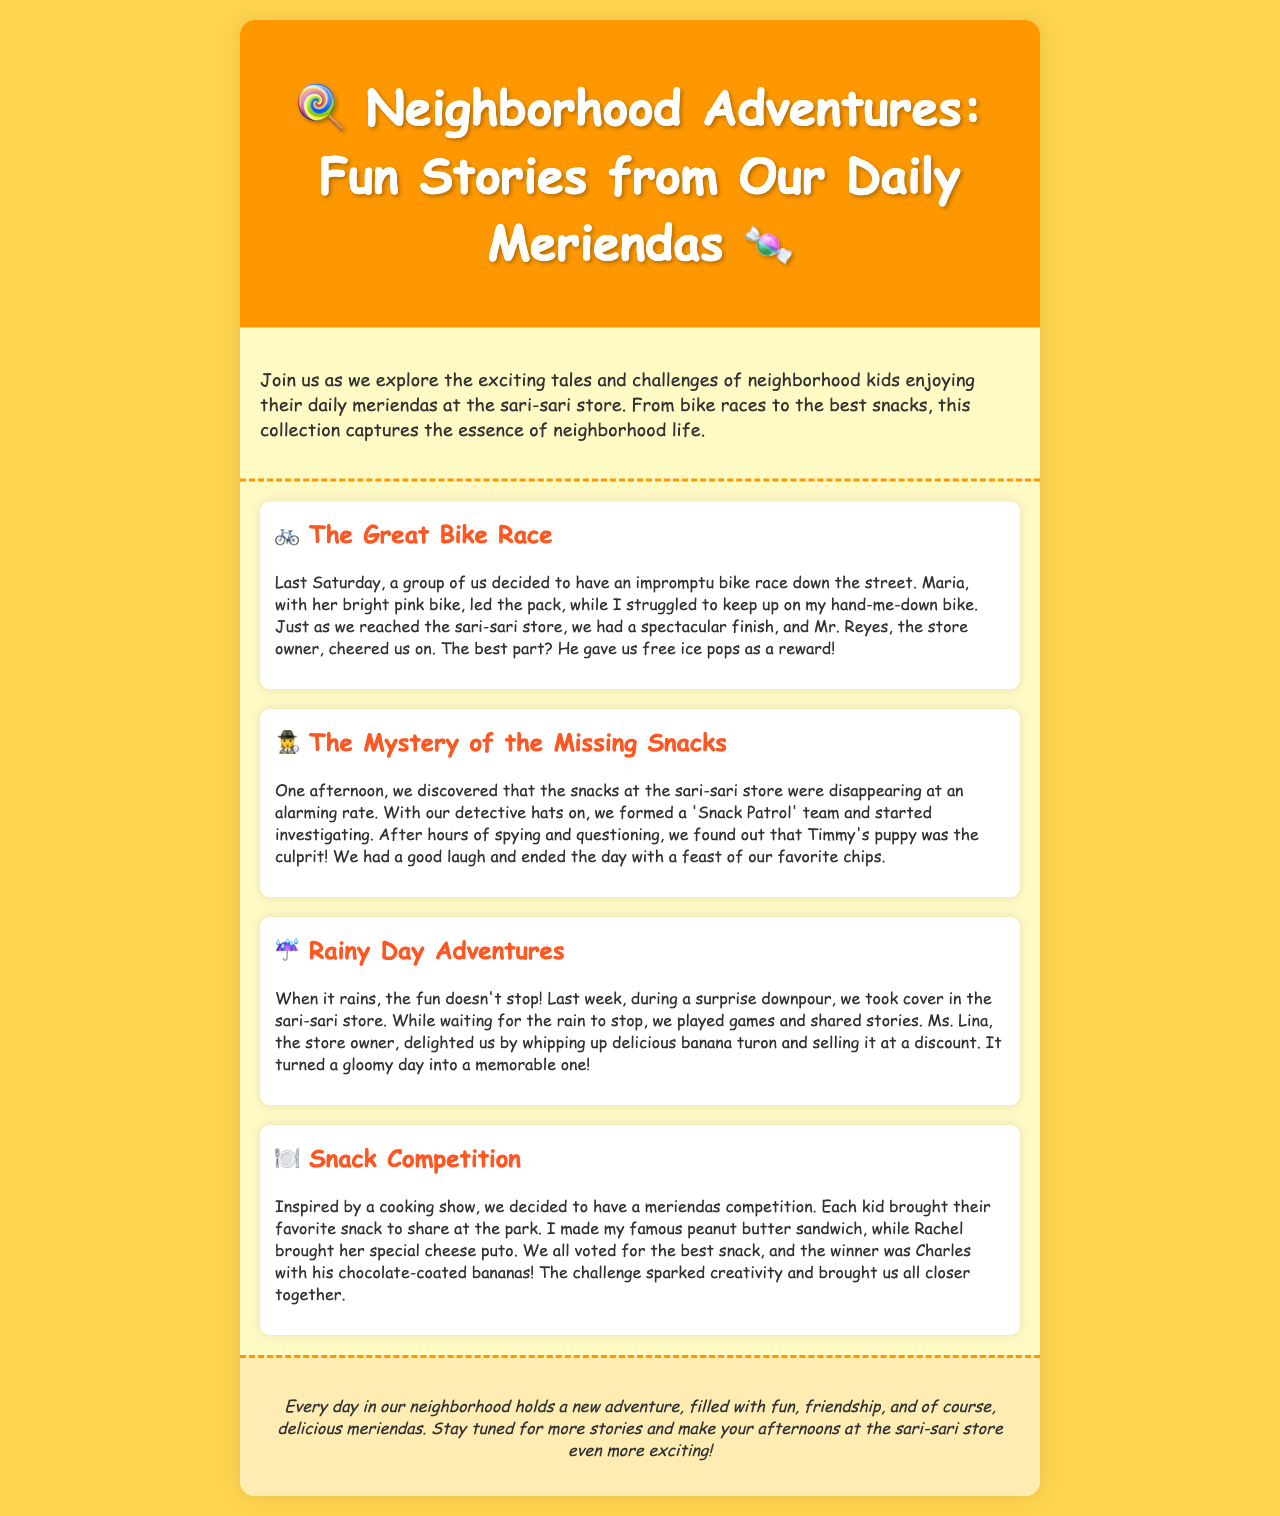What is the title of the newsletter? The title is found in the header of the document.
Answer: Neighborhood Adventures: Fun Stories from Our Daily Meriendas Who was the leader of the bike race? The leader of the bike race is mentioned in the story about The Great Bike Race.
Answer: Maria What did Mr. Reyes give the kids? Mr. Reyes's action is described in the context of the bike race story.
Answer: Free ice pops What was the puppy's name? The name of the puppy is revealed in the story about The Mystery of the Missing Snacks.
Answer: Timmy's puppy Which snack won the meriendas competition? The winner of the snack competition is detailed in the Snack Competition story.
Answer: Chocolate-coated bananas What did Ms. Lina sell during the rainy day? Ms. Lina's offering is mentioned in the Rainy Day Adventures story.
Answer: Delicious banana turon How many stories are included in the newsletter? The number of stories can be found by counting in the document.
Answer: Four What is the main theme of the newsletter? The main theme can be inferred from the introduction section.
Answer: Neighborhood adventures What type of document is this? The document's format can be recognized from its content and structure.
Answer: Newsletter 